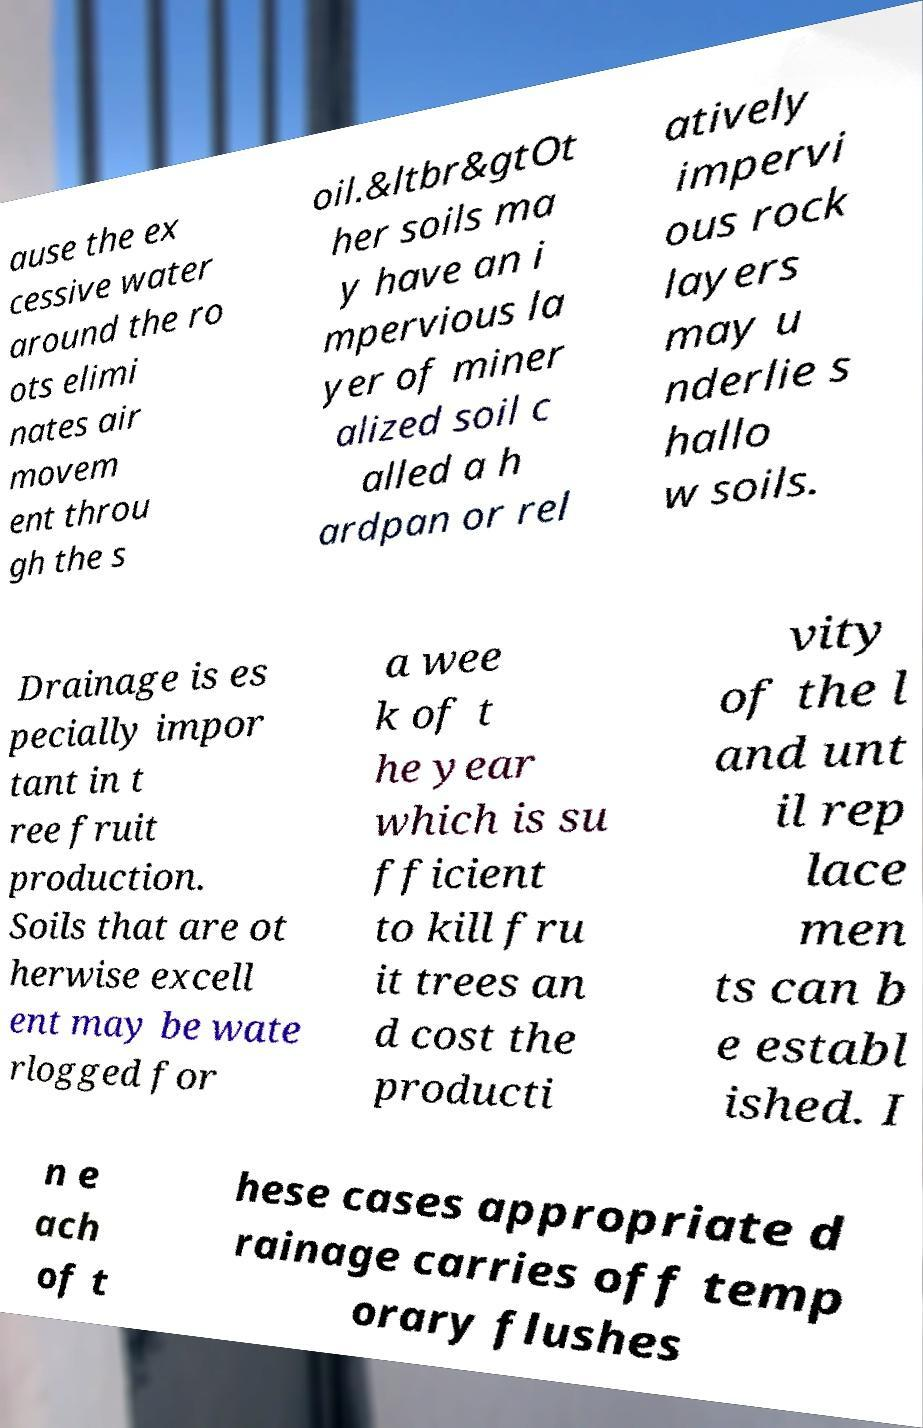Please identify and transcribe the text found in this image. ause the ex cessive water around the ro ots elimi nates air movem ent throu gh the s oil.&ltbr&gtOt her soils ma y have an i mpervious la yer of miner alized soil c alled a h ardpan or rel atively impervi ous rock layers may u nderlie s hallo w soils. Drainage is es pecially impor tant in t ree fruit production. Soils that are ot herwise excell ent may be wate rlogged for a wee k of t he year which is su fficient to kill fru it trees an d cost the producti vity of the l and unt il rep lace men ts can b e establ ished. I n e ach of t hese cases appropriate d rainage carries off temp orary flushes 